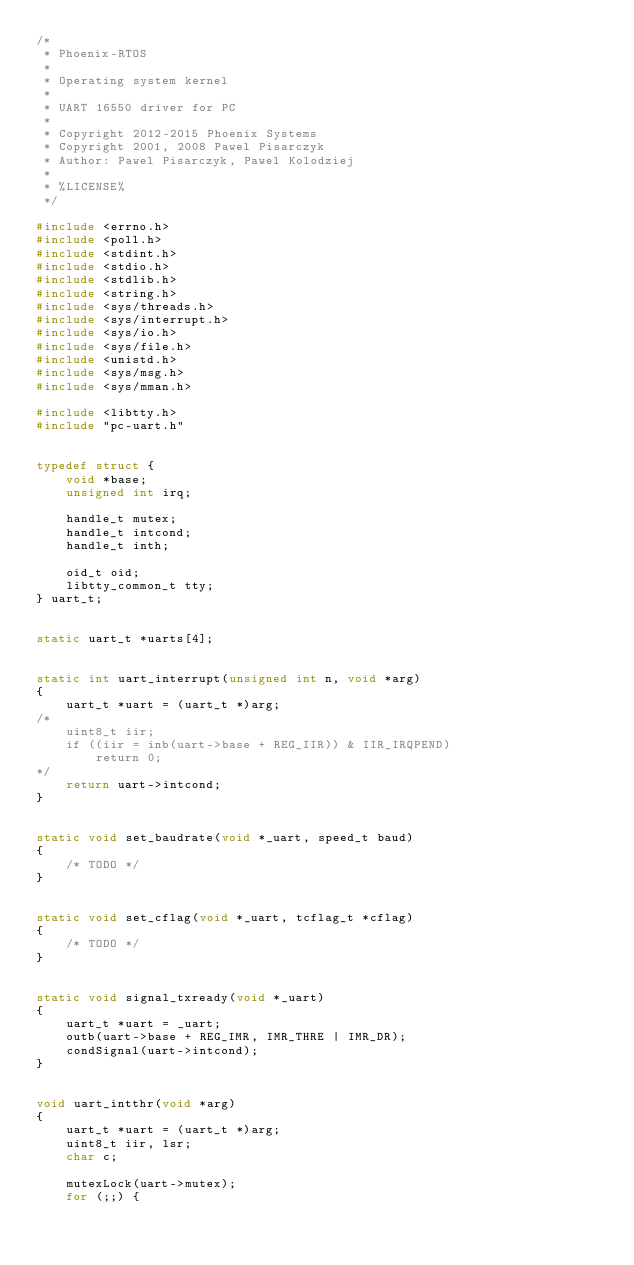Convert code to text. <code><loc_0><loc_0><loc_500><loc_500><_C_>/*
 * Phoenix-RTOS
 *
 * Operating system kernel
 *
 * UART 16550 driver for PC
 *
 * Copyright 2012-2015 Phoenix Systems
 * Copyright 2001, 2008 Pawel Pisarczyk
 * Author: Pawel Pisarczyk, Pawel Kolodziej
 *
 * %LICENSE%
 */

#include <errno.h>
#include <poll.h>
#include <stdint.h>
#include <stdio.h>
#include <stdlib.h>
#include <string.h>
#include <sys/threads.h>
#include <sys/interrupt.h>
#include <sys/io.h>
#include <sys/file.h>
#include <unistd.h>
#include <sys/msg.h>
#include <sys/mman.h>

#include <libtty.h>
#include "pc-uart.h"


typedef struct {
	void *base;
	unsigned int irq;

	handle_t mutex;
	handle_t intcond;
	handle_t inth;

	oid_t oid;
	libtty_common_t tty;
} uart_t;


static uart_t *uarts[4];


static int uart_interrupt(unsigned int n, void *arg)
{
	uart_t *uart = (uart_t *)arg;
/*
	uint8_t iir;
	if ((iir = inb(uart->base + REG_IIR)) & IIR_IRQPEND)
		return 0;
*/
	return uart->intcond;
}


static void set_baudrate(void *_uart, speed_t baud)
{
	/* TODO */
}


static void set_cflag(void *_uart, tcflag_t *cflag)
{
	/* TODO */
}


static void signal_txready(void *_uart)
{
	uart_t *uart = _uart;
	outb(uart->base + REG_IMR, IMR_THRE | IMR_DR);
	condSignal(uart->intcond);
}


void uart_intthr(void *arg)
{
	uart_t *uart = (uart_t *)arg;
	uint8_t iir, lsr;
	char c;

	mutexLock(uart->mutex);
	for (;;) {</code> 